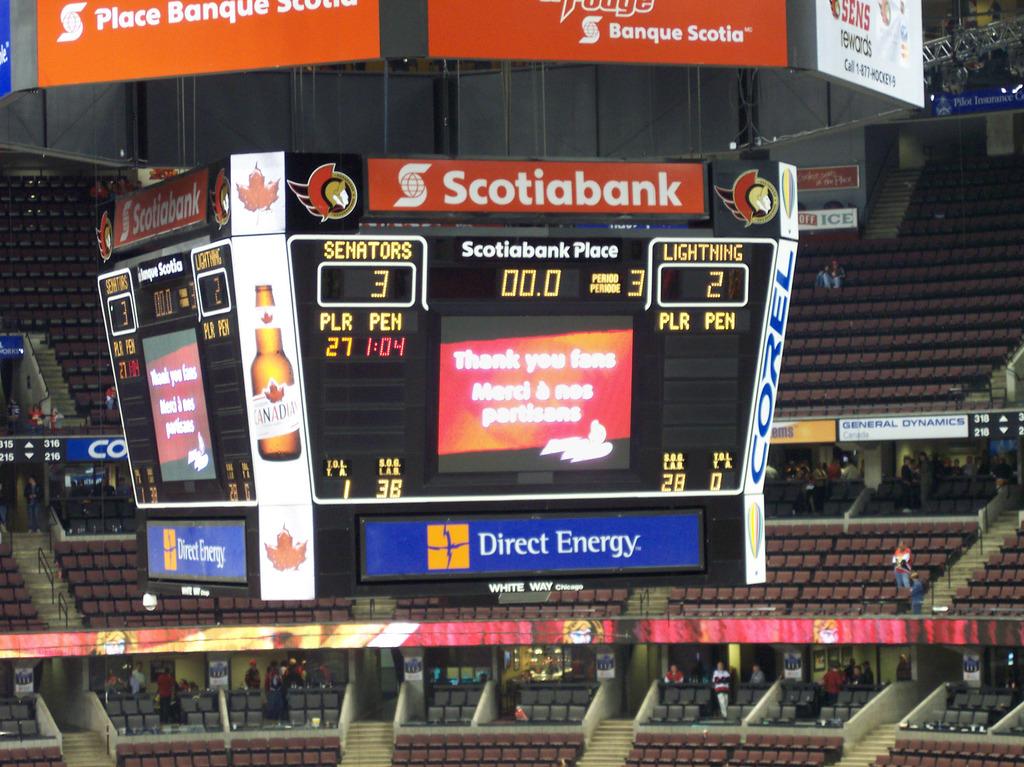Which company is the basketball arena named after?
Make the answer very short. Scotiabank. What is the score?
Ensure brevity in your answer.  3-2. 